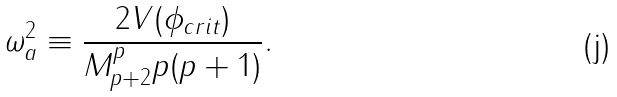<formula> <loc_0><loc_0><loc_500><loc_500>\omega _ { a } ^ { 2 } \equiv \frac { 2 V ( \phi _ { c r i t } ) } { M _ { p + 2 } ^ { p } p ( p + 1 ) } .</formula> 